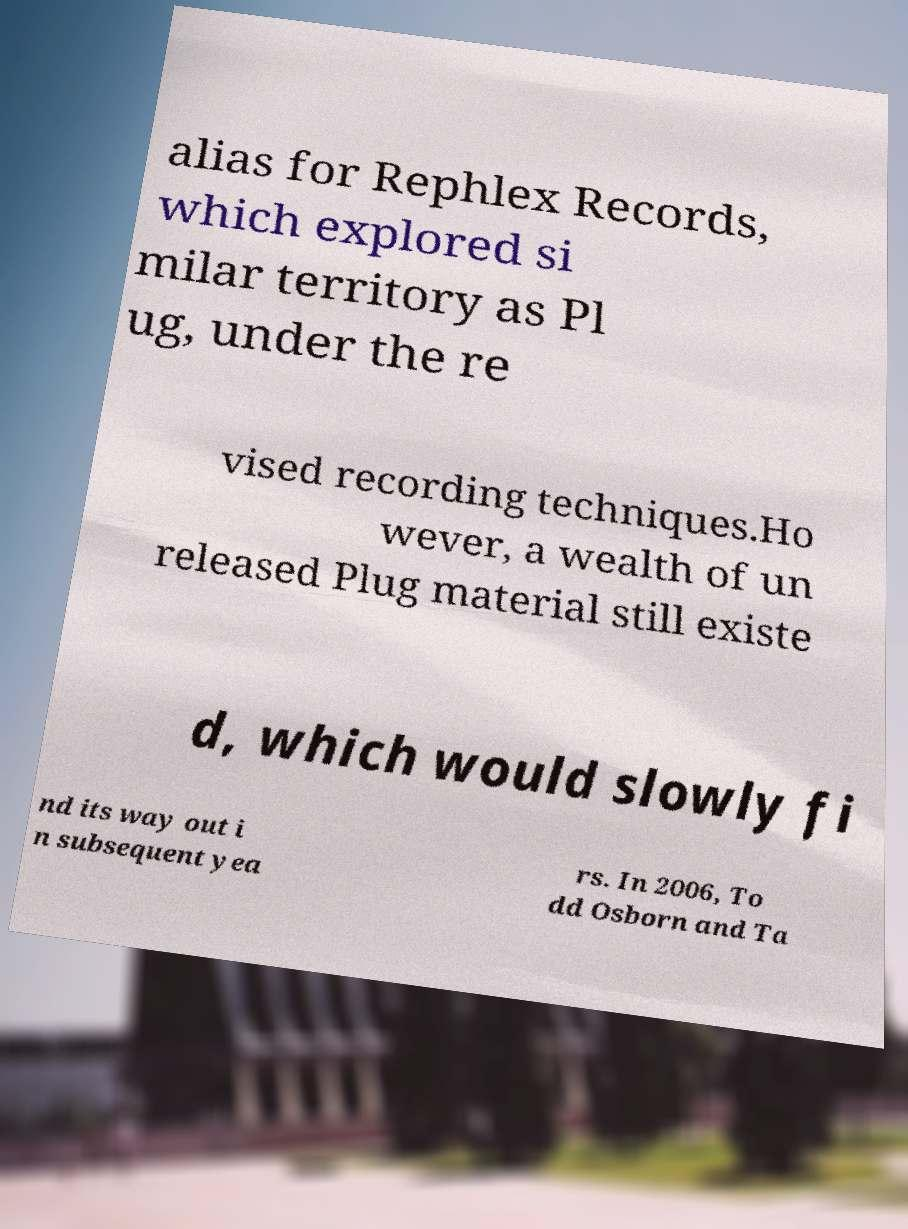Please read and relay the text visible in this image. What does it say? alias for Rephlex Records, which explored si milar territory as Pl ug, under the re vised recording techniques.Ho wever, a wealth of un released Plug material still existe d, which would slowly fi nd its way out i n subsequent yea rs. In 2006, To dd Osborn and Ta 